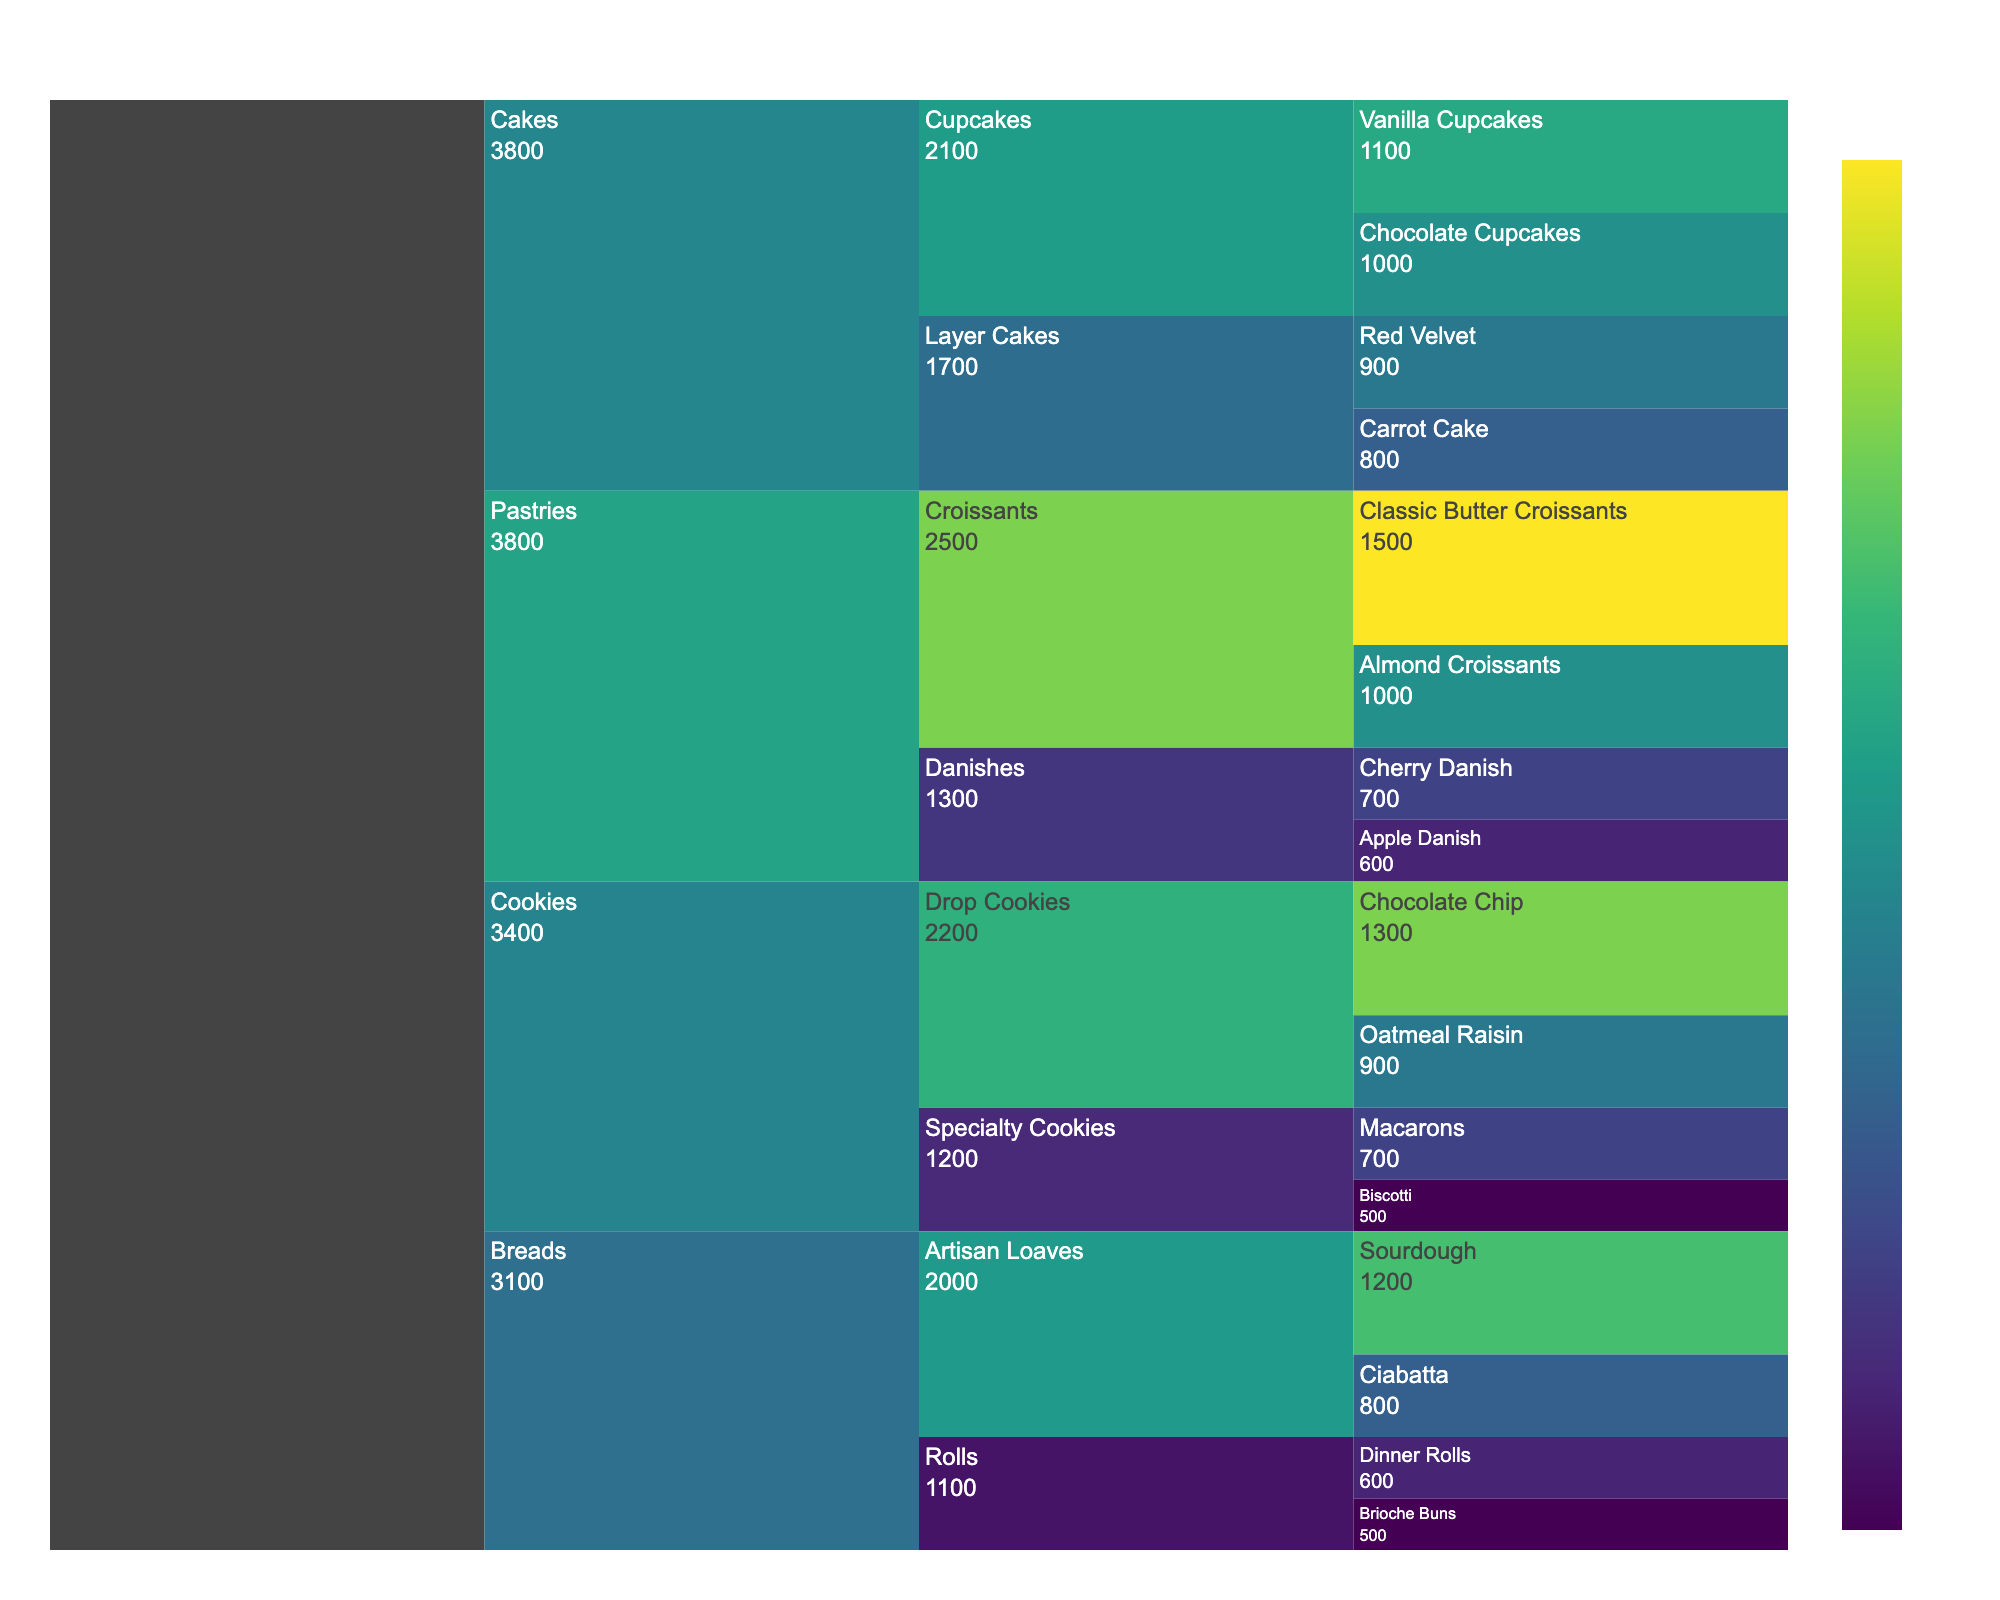What's the title of the figure? The title is usually located at the top of the figure, describing the content. Here, it's centered and says "Bakery Sales Breakdown."
Answer: Bakery Sales Breakdown Which product has the highest sales in the 'Pastries' category? Locate the 'Pastries' category, then find the product with the largest bar. 'Classic Butter Croissants' has the highest sales.
Answer: Classic Butter Croissants How many subcategories are there in the 'Breads' category? Identify the number of distinct branches under the 'Breads' category. There are 'Artisan Loaves' and 'Rolls'.
Answer: 2 Which subcategory in 'Cookies' has lower total sales: 'Drop Cookies' or 'Specialty Cookies'? Look at the total sales for each subcategory within 'Cookies'. 'Specialty Cookies' has lower total sales than 'Drop Cookies'.
Answer: Specialty Cookies What's the combined sales of 'Sourdough' and 'Ciabatta'? Add the sales numbers for 'Sourdough' and 'Ciabatta' under 'Artisan Loaves' in 'Breads'. 1200 + 800 = 2000.
Answer: 2000 Which has higher sales: 'Chocolate Chip' cookies or 'Almond Croissants'? Compare the sales values of 'Chocolate Chip' cookies under 'Drop Cookies' and 'Almond Croissants' under 'Croissants'. 'Chocolate Chip' cookies have higher sales.
Answer: Chocolate Chip cookies Rank the 'Cakes' subcategories from highest to lowest sales. Sort the sales values of 'Layer Cakes' and 'Cupcakes' in the 'Cakes' category. 'Cupcakes' (1100+1000) > 'Layer Cakes' (900+800).
Answer: Cupcakes, Layer Cakes In the 'Pastries' category, what is the difference in sales between 'Cherry Danish' and 'Apple Danish'? Subtract the sales of 'Apple Danish' from 'Cherry Danish'. 700 - 600 = 100.
Answer: 100 What is the total sales for all products in the 'Cookies' category? Sum the sales of all products in the 'Cookies' category: 1300 + 900 + 700 + 500 = 3400.
Answer: 3400 What color scale is used to represent sales values? The color scale represents values using shades associated with a specific palette. The figure uses the 'Viridis' color scale.
Answer: Viridis 